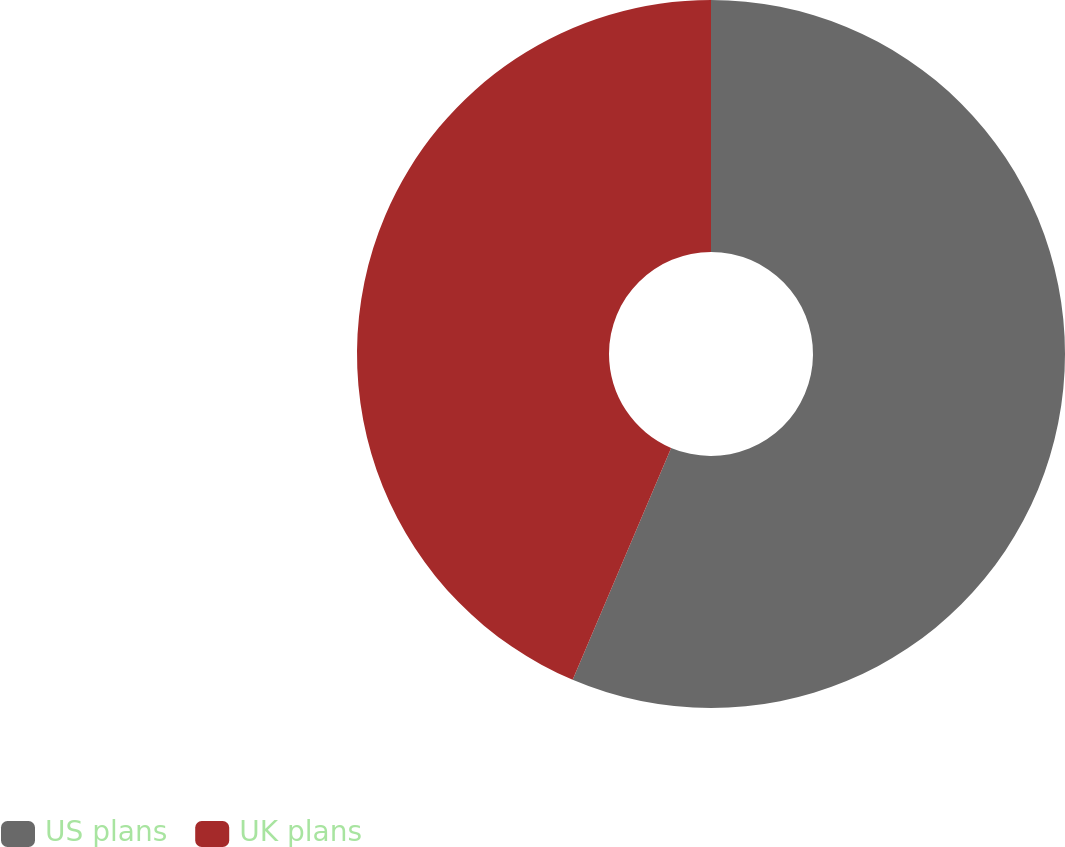<chart> <loc_0><loc_0><loc_500><loc_500><pie_chart><fcel>US plans<fcel>UK plans<nl><fcel>56.39%<fcel>43.61%<nl></chart> 